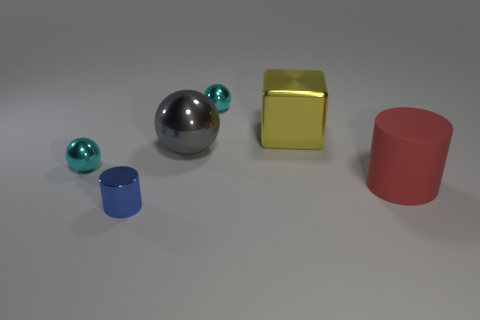Add 2 blue metallic cylinders. How many objects exist? 8 Subtract all cubes. How many objects are left? 5 Subtract all big gray shiny things. Subtract all tiny metallic spheres. How many objects are left? 3 Add 3 cyan spheres. How many cyan spheres are left? 5 Add 5 gray metallic objects. How many gray metallic objects exist? 6 Subtract 0 yellow balls. How many objects are left? 6 